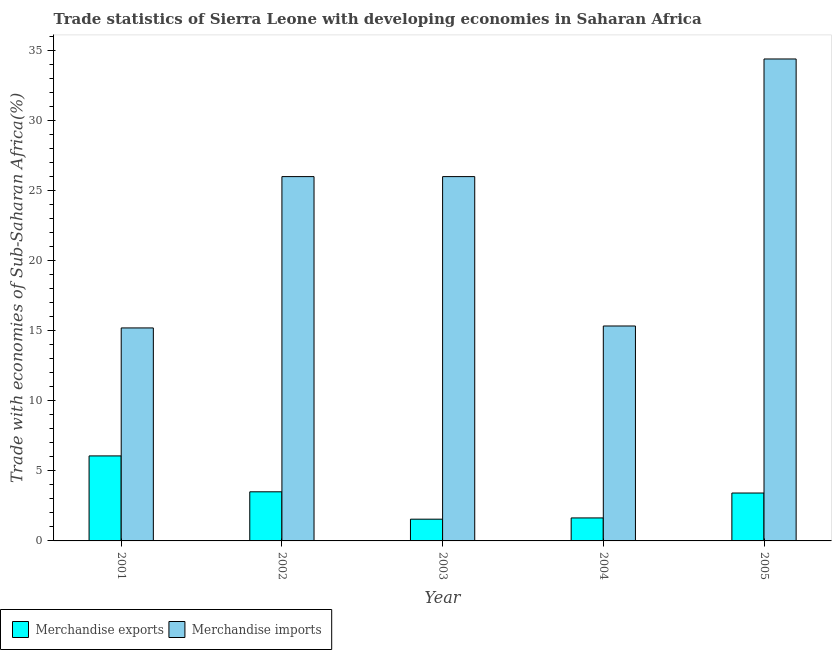How many different coloured bars are there?
Provide a short and direct response. 2. Are the number of bars per tick equal to the number of legend labels?
Provide a short and direct response. Yes. Are the number of bars on each tick of the X-axis equal?
Provide a short and direct response. Yes. How many bars are there on the 1st tick from the left?
Offer a very short reply. 2. In how many cases, is the number of bars for a given year not equal to the number of legend labels?
Offer a very short reply. 0. What is the merchandise imports in 2002?
Give a very brief answer. 26. Across all years, what is the maximum merchandise exports?
Provide a succinct answer. 6.07. Across all years, what is the minimum merchandise imports?
Provide a short and direct response. 15.2. In which year was the merchandise imports minimum?
Keep it short and to the point. 2001. What is the total merchandise exports in the graph?
Your response must be concise. 16.18. What is the difference between the merchandise exports in 2004 and that in 2005?
Provide a succinct answer. -1.78. What is the difference between the merchandise imports in 2001 and the merchandise exports in 2002?
Your answer should be very brief. -10.8. What is the average merchandise exports per year?
Provide a succinct answer. 3.24. In the year 2005, what is the difference between the merchandise exports and merchandise imports?
Keep it short and to the point. 0. In how many years, is the merchandise exports greater than 23 %?
Provide a short and direct response. 0. What is the ratio of the merchandise imports in 2001 to that in 2004?
Provide a succinct answer. 0.99. Is the merchandise imports in 2001 less than that in 2004?
Your answer should be very brief. Yes. What is the difference between the highest and the second highest merchandise imports?
Your response must be concise. 8.4. What is the difference between the highest and the lowest merchandise imports?
Your answer should be compact. 19.2. In how many years, is the merchandise exports greater than the average merchandise exports taken over all years?
Your response must be concise. 3. Are all the bars in the graph horizontal?
Give a very brief answer. No. How many years are there in the graph?
Your answer should be very brief. 5. What is the difference between two consecutive major ticks on the Y-axis?
Your answer should be compact. 5. Does the graph contain any zero values?
Provide a short and direct response. No. Where does the legend appear in the graph?
Offer a very short reply. Bottom left. How are the legend labels stacked?
Provide a succinct answer. Horizontal. What is the title of the graph?
Provide a succinct answer. Trade statistics of Sierra Leone with developing economies in Saharan Africa. Does "Female labourers" appear as one of the legend labels in the graph?
Your answer should be very brief. No. What is the label or title of the X-axis?
Provide a succinct answer. Year. What is the label or title of the Y-axis?
Offer a terse response. Trade with economies of Sub-Saharan Africa(%). What is the Trade with economies of Sub-Saharan Africa(%) of Merchandise exports in 2001?
Your response must be concise. 6.07. What is the Trade with economies of Sub-Saharan Africa(%) of Merchandise imports in 2001?
Your answer should be very brief. 15.2. What is the Trade with economies of Sub-Saharan Africa(%) in Merchandise exports in 2002?
Ensure brevity in your answer.  3.51. What is the Trade with economies of Sub-Saharan Africa(%) of Merchandise imports in 2002?
Offer a very short reply. 26. What is the Trade with economies of Sub-Saharan Africa(%) of Merchandise exports in 2003?
Provide a short and direct response. 1.55. What is the Trade with economies of Sub-Saharan Africa(%) of Merchandise imports in 2003?
Your answer should be very brief. 26. What is the Trade with economies of Sub-Saharan Africa(%) of Merchandise exports in 2004?
Your response must be concise. 1.64. What is the Trade with economies of Sub-Saharan Africa(%) in Merchandise imports in 2004?
Give a very brief answer. 15.34. What is the Trade with economies of Sub-Saharan Africa(%) in Merchandise exports in 2005?
Make the answer very short. 3.42. What is the Trade with economies of Sub-Saharan Africa(%) in Merchandise imports in 2005?
Make the answer very short. 34.4. Across all years, what is the maximum Trade with economies of Sub-Saharan Africa(%) of Merchandise exports?
Your answer should be compact. 6.07. Across all years, what is the maximum Trade with economies of Sub-Saharan Africa(%) in Merchandise imports?
Provide a short and direct response. 34.4. Across all years, what is the minimum Trade with economies of Sub-Saharan Africa(%) in Merchandise exports?
Your answer should be compact. 1.55. Across all years, what is the minimum Trade with economies of Sub-Saharan Africa(%) of Merchandise imports?
Provide a succinct answer. 15.2. What is the total Trade with economies of Sub-Saharan Africa(%) of Merchandise exports in the graph?
Provide a short and direct response. 16.18. What is the total Trade with economies of Sub-Saharan Africa(%) of Merchandise imports in the graph?
Provide a succinct answer. 116.95. What is the difference between the Trade with economies of Sub-Saharan Africa(%) in Merchandise exports in 2001 and that in 2002?
Provide a succinct answer. 2.56. What is the difference between the Trade with economies of Sub-Saharan Africa(%) of Merchandise imports in 2001 and that in 2002?
Provide a short and direct response. -10.8. What is the difference between the Trade with economies of Sub-Saharan Africa(%) of Merchandise exports in 2001 and that in 2003?
Your response must be concise. 4.52. What is the difference between the Trade with economies of Sub-Saharan Africa(%) of Merchandise imports in 2001 and that in 2003?
Offer a terse response. -10.8. What is the difference between the Trade with economies of Sub-Saharan Africa(%) of Merchandise exports in 2001 and that in 2004?
Make the answer very short. 4.43. What is the difference between the Trade with economies of Sub-Saharan Africa(%) of Merchandise imports in 2001 and that in 2004?
Offer a very short reply. -0.14. What is the difference between the Trade with economies of Sub-Saharan Africa(%) in Merchandise exports in 2001 and that in 2005?
Your response must be concise. 2.65. What is the difference between the Trade with economies of Sub-Saharan Africa(%) in Merchandise imports in 2001 and that in 2005?
Make the answer very short. -19.2. What is the difference between the Trade with economies of Sub-Saharan Africa(%) of Merchandise exports in 2002 and that in 2003?
Your answer should be compact. 1.95. What is the difference between the Trade with economies of Sub-Saharan Africa(%) of Merchandise imports in 2002 and that in 2003?
Your answer should be very brief. -0. What is the difference between the Trade with economies of Sub-Saharan Africa(%) of Merchandise exports in 2002 and that in 2004?
Your response must be concise. 1.86. What is the difference between the Trade with economies of Sub-Saharan Africa(%) in Merchandise imports in 2002 and that in 2004?
Offer a very short reply. 10.66. What is the difference between the Trade with economies of Sub-Saharan Africa(%) in Merchandise exports in 2002 and that in 2005?
Offer a terse response. 0.09. What is the difference between the Trade with economies of Sub-Saharan Africa(%) of Merchandise imports in 2002 and that in 2005?
Provide a short and direct response. -8.4. What is the difference between the Trade with economies of Sub-Saharan Africa(%) of Merchandise exports in 2003 and that in 2004?
Offer a terse response. -0.09. What is the difference between the Trade with economies of Sub-Saharan Africa(%) in Merchandise imports in 2003 and that in 2004?
Ensure brevity in your answer.  10.66. What is the difference between the Trade with economies of Sub-Saharan Africa(%) of Merchandise exports in 2003 and that in 2005?
Ensure brevity in your answer.  -1.87. What is the difference between the Trade with economies of Sub-Saharan Africa(%) of Merchandise imports in 2003 and that in 2005?
Offer a very short reply. -8.4. What is the difference between the Trade with economies of Sub-Saharan Africa(%) of Merchandise exports in 2004 and that in 2005?
Keep it short and to the point. -1.78. What is the difference between the Trade with economies of Sub-Saharan Africa(%) in Merchandise imports in 2004 and that in 2005?
Make the answer very short. -19.06. What is the difference between the Trade with economies of Sub-Saharan Africa(%) in Merchandise exports in 2001 and the Trade with economies of Sub-Saharan Africa(%) in Merchandise imports in 2002?
Provide a succinct answer. -19.94. What is the difference between the Trade with economies of Sub-Saharan Africa(%) in Merchandise exports in 2001 and the Trade with economies of Sub-Saharan Africa(%) in Merchandise imports in 2003?
Ensure brevity in your answer.  -19.94. What is the difference between the Trade with economies of Sub-Saharan Africa(%) in Merchandise exports in 2001 and the Trade with economies of Sub-Saharan Africa(%) in Merchandise imports in 2004?
Keep it short and to the point. -9.27. What is the difference between the Trade with economies of Sub-Saharan Africa(%) of Merchandise exports in 2001 and the Trade with economies of Sub-Saharan Africa(%) of Merchandise imports in 2005?
Make the answer very short. -28.33. What is the difference between the Trade with economies of Sub-Saharan Africa(%) of Merchandise exports in 2002 and the Trade with economies of Sub-Saharan Africa(%) of Merchandise imports in 2003?
Provide a succinct answer. -22.5. What is the difference between the Trade with economies of Sub-Saharan Africa(%) in Merchandise exports in 2002 and the Trade with economies of Sub-Saharan Africa(%) in Merchandise imports in 2004?
Give a very brief answer. -11.84. What is the difference between the Trade with economies of Sub-Saharan Africa(%) in Merchandise exports in 2002 and the Trade with economies of Sub-Saharan Africa(%) in Merchandise imports in 2005?
Your answer should be compact. -30.89. What is the difference between the Trade with economies of Sub-Saharan Africa(%) of Merchandise exports in 2003 and the Trade with economies of Sub-Saharan Africa(%) of Merchandise imports in 2004?
Offer a terse response. -13.79. What is the difference between the Trade with economies of Sub-Saharan Africa(%) in Merchandise exports in 2003 and the Trade with economies of Sub-Saharan Africa(%) in Merchandise imports in 2005?
Provide a short and direct response. -32.85. What is the difference between the Trade with economies of Sub-Saharan Africa(%) in Merchandise exports in 2004 and the Trade with economies of Sub-Saharan Africa(%) in Merchandise imports in 2005?
Ensure brevity in your answer.  -32.76. What is the average Trade with economies of Sub-Saharan Africa(%) in Merchandise exports per year?
Ensure brevity in your answer.  3.24. What is the average Trade with economies of Sub-Saharan Africa(%) in Merchandise imports per year?
Provide a succinct answer. 23.39. In the year 2001, what is the difference between the Trade with economies of Sub-Saharan Africa(%) of Merchandise exports and Trade with economies of Sub-Saharan Africa(%) of Merchandise imports?
Keep it short and to the point. -9.14. In the year 2002, what is the difference between the Trade with economies of Sub-Saharan Africa(%) in Merchandise exports and Trade with economies of Sub-Saharan Africa(%) in Merchandise imports?
Make the answer very short. -22.5. In the year 2003, what is the difference between the Trade with economies of Sub-Saharan Africa(%) of Merchandise exports and Trade with economies of Sub-Saharan Africa(%) of Merchandise imports?
Ensure brevity in your answer.  -24.45. In the year 2004, what is the difference between the Trade with economies of Sub-Saharan Africa(%) of Merchandise exports and Trade with economies of Sub-Saharan Africa(%) of Merchandise imports?
Your response must be concise. -13.7. In the year 2005, what is the difference between the Trade with economies of Sub-Saharan Africa(%) in Merchandise exports and Trade with economies of Sub-Saharan Africa(%) in Merchandise imports?
Keep it short and to the point. -30.98. What is the ratio of the Trade with economies of Sub-Saharan Africa(%) in Merchandise exports in 2001 to that in 2002?
Make the answer very short. 1.73. What is the ratio of the Trade with economies of Sub-Saharan Africa(%) in Merchandise imports in 2001 to that in 2002?
Provide a succinct answer. 0.58. What is the ratio of the Trade with economies of Sub-Saharan Africa(%) in Merchandise exports in 2001 to that in 2003?
Provide a succinct answer. 3.91. What is the ratio of the Trade with economies of Sub-Saharan Africa(%) in Merchandise imports in 2001 to that in 2003?
Provide a succinct answer. 0.58. What is the ratio of the Trade with economies of Sub-Saharan Africa(%) of Merchandise exports in 2001 to that in 2004?
Give a very brief answer. 3.7. What is the ratio of the Trade with economies of Sub-Saharan Africa(%) in Merchandise imports in 2001 to that in 2004?
Your answer should be compact. 0.99. What is the ratio of the Trade with economies of Sub-Saharan Africa(%) in Merchandise exports in 2001 to that in 2005?
Your answer should be compact. 1.77. What is the ratio of the Trade with economies of Sub-Saharan Africa(%) in Merchandise imports in 2001 to that in 2005?
Offer a terse response. 0.44. What is the ratio of the Trade with economies of Sub-Saharan Africa(%) of Merchandise exports in 2002 to that in 2003?
Give a very brief answer. 2.26. What is the ratio of the Trade with economies of Sub-Saharan Africa(%) in Merchandise imports in 2002 to that in 2003?
Ensure brevity in your answer.  1. What is the ratio of the Trade with economies of Sub-Saharan Africa(%) of Merchandise exports in 2002 to that in 2004?
Offer a very short reply. 2.14. What is the ratio of the Trade with economies of Sub-Saharan Africa(%) in Merchandise imports in 2002 to that in 2004?
Make the answer very short. 1.7. What is the ratio of the Trade with economies of Sub-Saharan Africa(%) in Merchandise exports in 2002 to that in 2005?
Your response must be concise. 1.03. What is the ratio of the Trade with economies of Sub-Saharan Africa(%) in Merchandise imports in 2002 to that in 2005?
Your response must be concise. 0.76. What is the ratio of the Trade with economies of Sub-Saharan Africa(%) in Merchandise exports in 2003 to that in 2004?
Your answer should be compact. 0.95. What is the ratio of the Trade with economies of Sub-Saharan Africa(%) of Merchandise imports in 2003 to that in 2004?
Provide a short and direct response. 1.7. What is the ratio of the Trade with economies of Sub-Saharan Africa(%) of Merchandise exports in 2003 to that in 2005?
Make the answer very short. 0.45. What is the ratio of the Trade with economies of Sub-Saharan Africa(%) of Merchandise imports in 2003 to that in 2005?
Ensure brevity in your answer.  0.76. What is the ratio of the Trade with economies of Sub-Saharan Africa(%) in Merchandise exports in 2004 to that in 2005?
Provide a succinct answer. 0.48. What is the ratio of the Trade with economies of Sub-Saharan Africa(%) of Merchandise imports in 2004 to that in 2005?
Keep it short and to the point. 0.45. What is the difference between the highest and the second highest Trade with economies of Sub-Saharan Africa(%) of Merchandise exports?
Ensure brevity in your answer.  2.56. What is the difference between the highest and the second highest Trade with economies of Sub-Saharan Africa(%) of Merchandise imports?
Offer a terse response. 8.4. What is the difference between the highest and the lowest Trade with economies of Sub-Saharan Africa(%) of Merchandise exports?
Offer a very short reply. 4.52. What is the difference between the highest and the lowest Trade with economies of Sub-Saharan Africa(%) in Merchandise imports?
Make the answer very short. 19.2. 